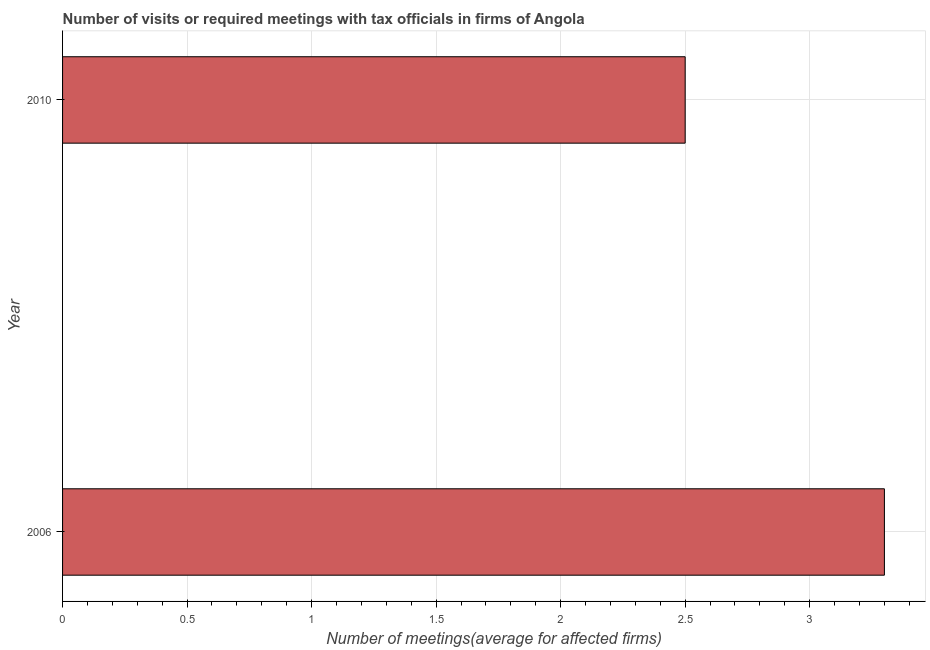What is the title of the graph?
Provide a short and direct response. Number of visits or required meetings with tax officials in firms of Angola. What is the label or title of the X-axis?
Make the answer very short. Number of meetings(average for affected firms). What is the label or title of the Y-axis?
Provide a succinct answer. Year. Across all years, what is the minimum number of required meetings with tax officials?
Offer a terse response. 2.5. In which year was the number of required meetings with tax officials maximum?
Provide a short and direct response. 2006. In which year was the number of required meetings with tax officials minimum?
Offer a terse response. 2010. What is the sum of the number of required meetings with tax officials?
Make the answer very short. 5.8. What is the difference between the number of required meetings with tax officials in 2006 and 2010?
Provide a short and direct response. 0.8. What is the median number of required meetings with tax officials?
Ensure brevity in your answer.  2.9. In how many years, is the number of required meetings with tax officials greater than 1.4 ?
Offer a very short reply. 2. What is the ratio of the number of required meetings with tax officials in 2006 to that in 2010?
Your answer should be very brief. 1.32. Is the number of required meetings with tax officials in 2006 less than that in 2010?
Your answer should be very brief. No. How many bars are there?
Offer a very short reply. 2. What is the Number of meetings(average for affected firms) of 2010?
Offer a terse response. 2.5. What is the difference between the Number of meetings(average for affected firms) in 2006 and 2010?
Make the answer very short. 0.8. What is the ratio of the Number of meetings(average for affected firms) in 2006 to that in 2010?
Provide a short and direct response. 1.32. 